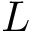<formula> <loc_0><loc_0><loc_500><loc_500>L</formula> 